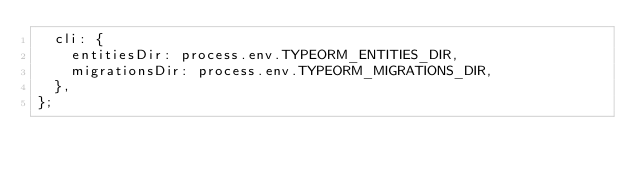Convert code to text. <code><loc_0><loc_0><loc_500><loc_500><_TypeScript_>  cli: {
    entitiesDir: process.env.TYPEORM_ENTITIES_DIR,
    migrationsDir: process.env.TYPEORM_MIGRATIONS_DIR,
  },
};
</code> 